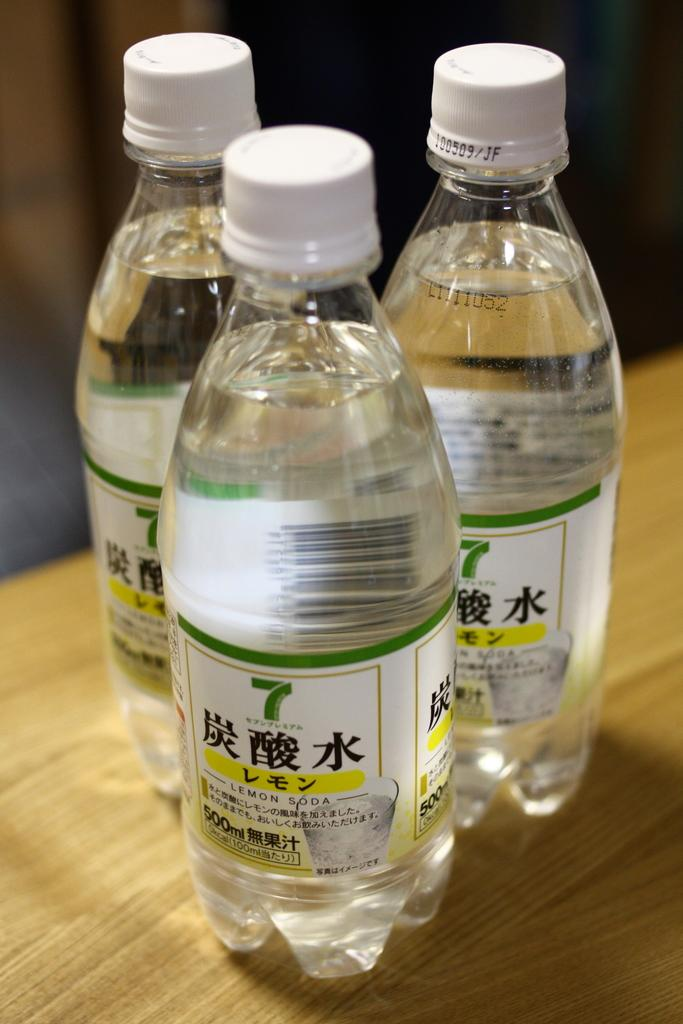<image>
Provide a brief description of the given image. Three bottles of lemon soda with the number 7 sit on a table. 